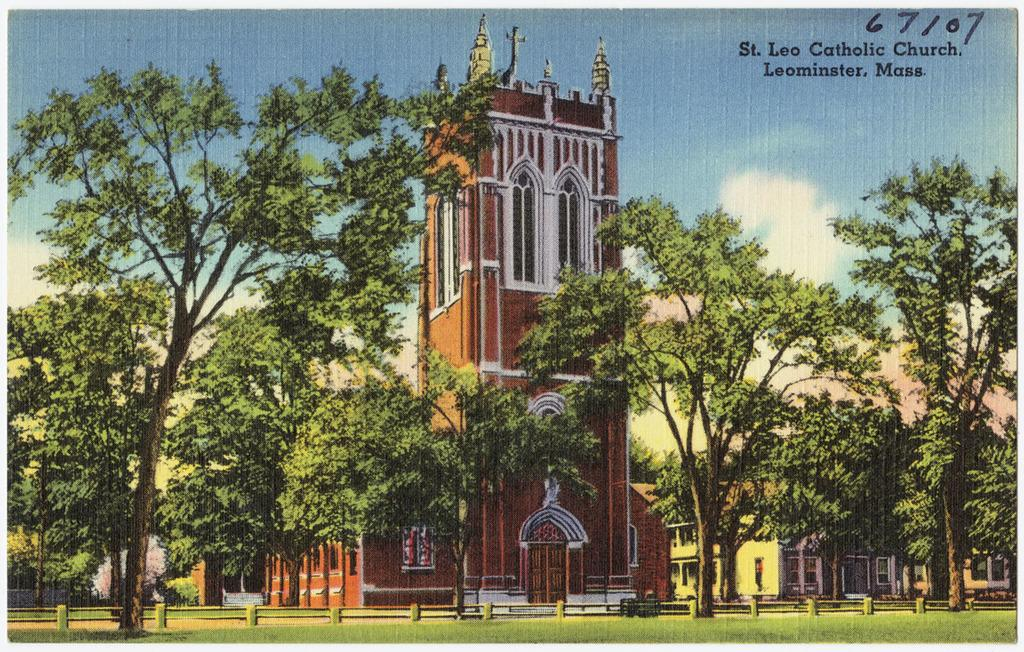<image>
Provide a brief description of the given image. A postcard of St Leo Catholic Church located in Leominister, Mass. 